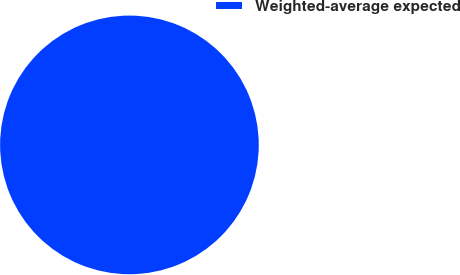Convert chart to OTSL. <chart><loc_0><loc_0><loc_500><loc_500><pie_chart><fcel>Weighted-average expected<nl><fcel>100.0%<nl></chart> 